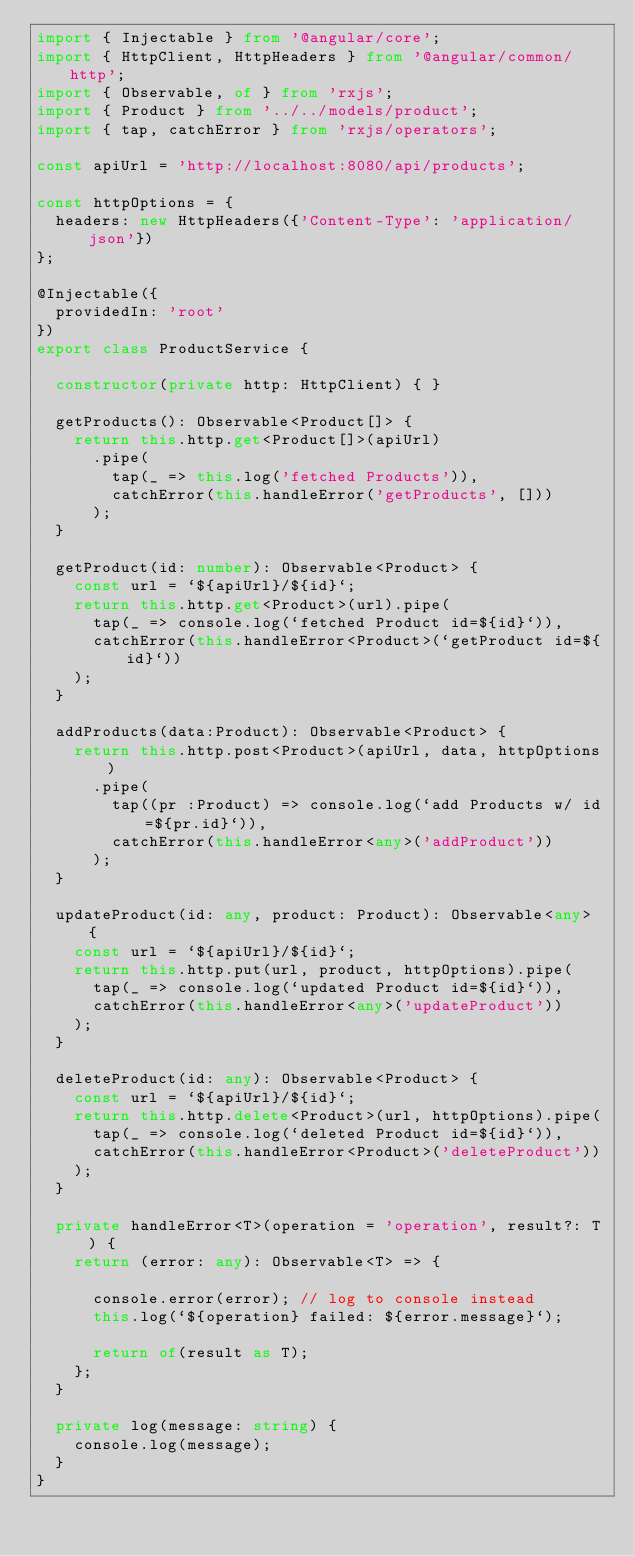<code> <loc_0><loc_0><loc_500><loc_500><_TypeScript_>import { Injectable } from '@angular/core';
import { HttpClient, HttpHeaders } from '@angular/common/http';
import { Observable, of } from 'rxjs';
import { Product } from '../../models/product';
import { tap, catchError } from 'rxjs/operators';

const apiUrl = 'http://localhost:8080/api/products';

const httpOptions = {
  headers: new HttpHeaders({'Content-Type': 'application/json'})
};

@Injectable({
  providedIn: 'root'
})
export class ProductService {

  constructor(private http: HttpClient) { }

  getProducts(): Observable<Product[]> {
    return this.http.get<Product[]>(apiUrl)
      .pipe(
        tap(_ => this.log('fetched Products')),
        catchError(this.handleError('getProducts', []))
      );
  }

  getProduct(id: number): Observable<Product> {
    const url = `${apiUrl}/${id}`;
    return this.http.get<Product>(url).pipe(
      tap(_ => console.log(`fetched Product id=${id}`)),
      catchError(this.handleError<Product>(`getProduct id=${id}`))
    );
  }

  addProducts(data:Product): Observable<Product> {
    return this.http.post<Product>(apiUrl, data, httpOptions)
      .pipe(
        tap((pr :Product) => console.log(`add Products w/ id=${pr.id}`)),
        catchError(this.handleError<any>('addProduct'))
      );
  }

  updateProduct(id: any, product: Product): Observable<any> {
    const url = `${apiUrl}/${id}`;
    return this.http.put(url, product, httpOptions).pipe(
      tap(_ => console.log(`updated Product id=${id}`)),
      catchError(this.handleError<any>('updateProduct'))
    );
  }

  deleteProduct(id: any): Observable<Product> {
    const url = `${apiUrl}/${id}`;
    return this.http.delete<Product>(url, httpOptions).pipe(
      tap(_ => console.log(`deleted Product id=${id}`)),
      catchError(this.handleError<Product>('deleteProduct'))
    );
  }

  private handleError<T>(operation = 'operation', result?: T) {
    return (error: any): Observable<T> => {

      console.error(error); // log to console instead
      this.log(`${operation} failed: ${error.message}`);

      return of(result as T);
    };
  }

  private log(message: string) {
    console.log(message);
  }
}</code> 